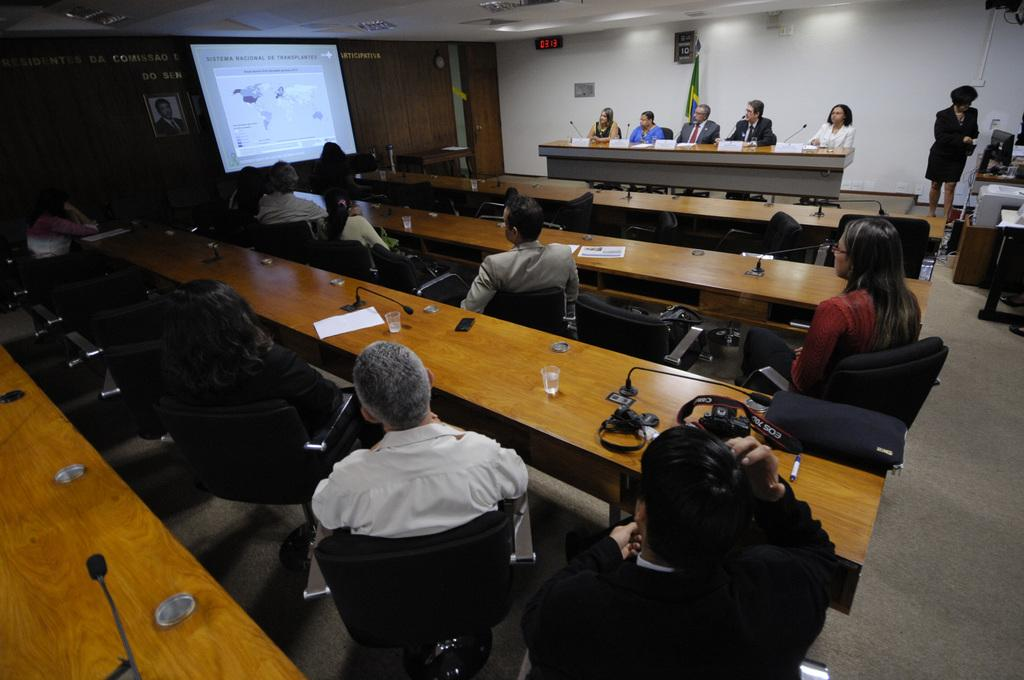Where was the image taken? The image was taken in a conference hall. What are the people in the image doing? People are sitting in chairs. What objects are in front of the chairs? Tables are present in front of the chairs. What activity is happening in the conference hall? A presentation is taking place. How many organizations are represented by the people sitting in the chairs? The image does not provide information about the number of organizations represented by the people sitting in the chairs. What type of balance is being maintained by the presenter during the presentation? There is no information about the presenter's balance during the presentation. 